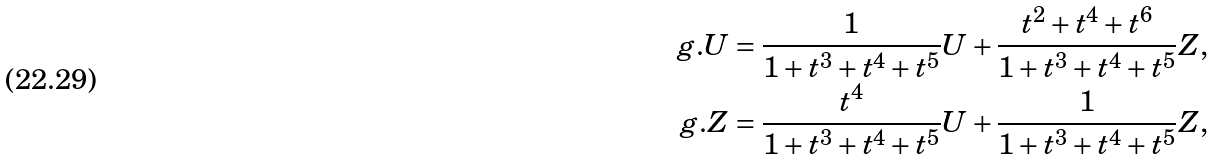<formula> <loc_0><loc_0><loc_500><loc_500>g . U = \frac { 1 } { 1 + t ^ { 3 } + t ^ { 4 } + t ^ { 5 } } U + \frac { t ^ { 2 } + t ^ { 4 } + t ^ { 6 } } { 1 + t ^ { 3 } + t ^ { 4 } + t ^ { 5 } } Z , \\ g . Z = \frac { t ^ { 4 } } { 1 + t ^ { 3 } + t ^ { 4 } + t ^ { 5 } } U + \frac { 1 } { 1 + t ^ { 3 } + t ^ { 4 } + t ^ { 5 } } Z ,</formula> 